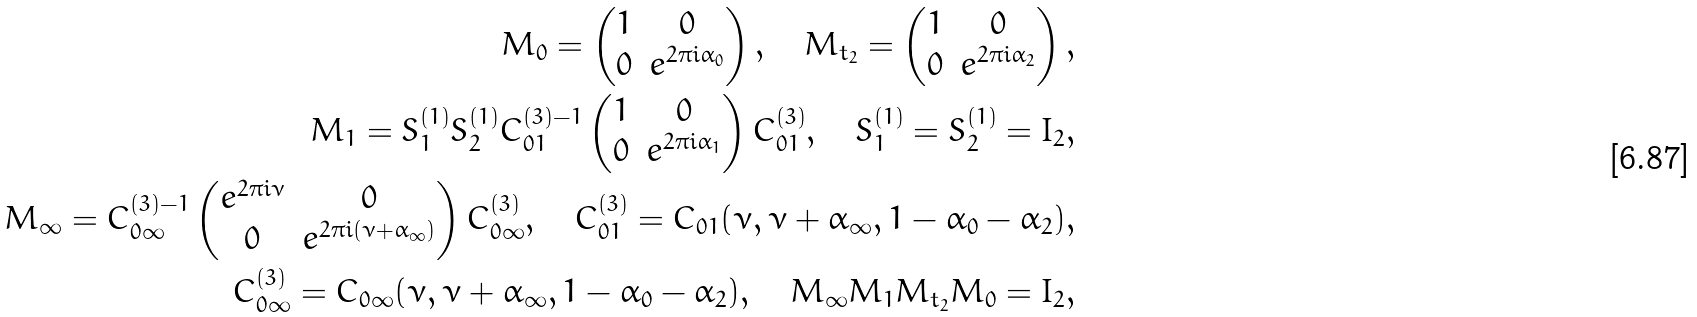<formula> <loc_0><loc_0><loc_500><loc_500>M _ { 0 } = \left ( \begin{matrix} 1 & 0 \\ 0 & e ^ { 2 \pi i \alpha _ { 0 } } \end{matrix} \right ) , \quad M _ { t _ { 2 } } = \left ( \begin{matrix} 1 & 0 \\ 0 & e ^ { 2 \pi i \alpha _ { 2 } } \end{matrix} \right ) , \\ M _ { 1 } = S _ { 1 } ^ { ( 1 ) } S _ { 2 } ^ { ( 1 ) } C _ { 0 1 } ^ { ( 3 ) - 1 } \left ( \begin{matrix} 1 & 0 \\ 0 & e ^ { 2 \pi i \alpha _ { 1 } } \end{matrix} \right ) C _ { 0 1 } ^ { ( 3 ) } , \quad S _ { 1 } ^ { ( 1 ) } = S _ { 2 } ^ { ( 1 ) } = I _ { 2 } , \\ M _ { \infty } = C _ { 0 \infty } ^ { ( 3 ) - 1 } \left ( \begin{matrix} e ^ { 2 \pi i \nu } & 0 \\ 0 & e ^ { 2 \pi i ( \nu + \alpha _ { \infty } ) } \end{matrix} \right ) C _ { 0 \infty } ^ { ( 3 ) } , \quad C _ { 0 1 } ^ { ( 3 ) } = C _ { 0 1 } ( \nu , \nu + \alpha _ { \infty } , 1 - \alpha _ { 0 } - \alpha _ { 2 } ) , \\ C _ { 0 \infty } ^ { ( 3 ) } = C _ { 0 \infty } ( \nu , \nu + \alpha _ { \infty } , 1 - \alpha _ { 0 } - \alpha _ { 2 } ) , \quad M _ { \infty } M _ { 1 } M _ { t _ { 2 } } M _ { 0 } = I _ { 2 } ,</formula> 